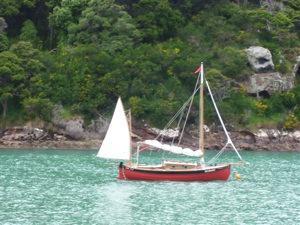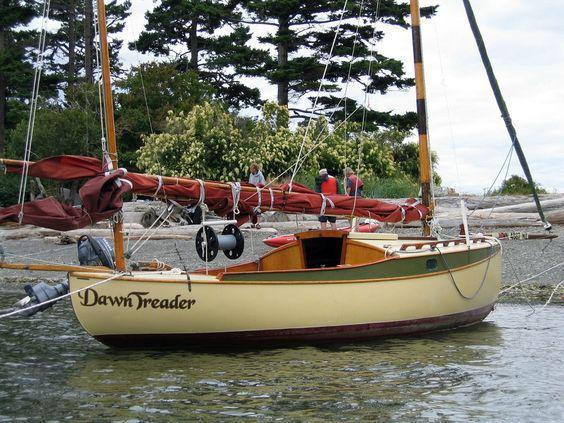The first image is the image on the left, the second image is the image on the right. For the images shown, is this caption "The boat in the right image has its sails up." true? Answer yes or no. No. 